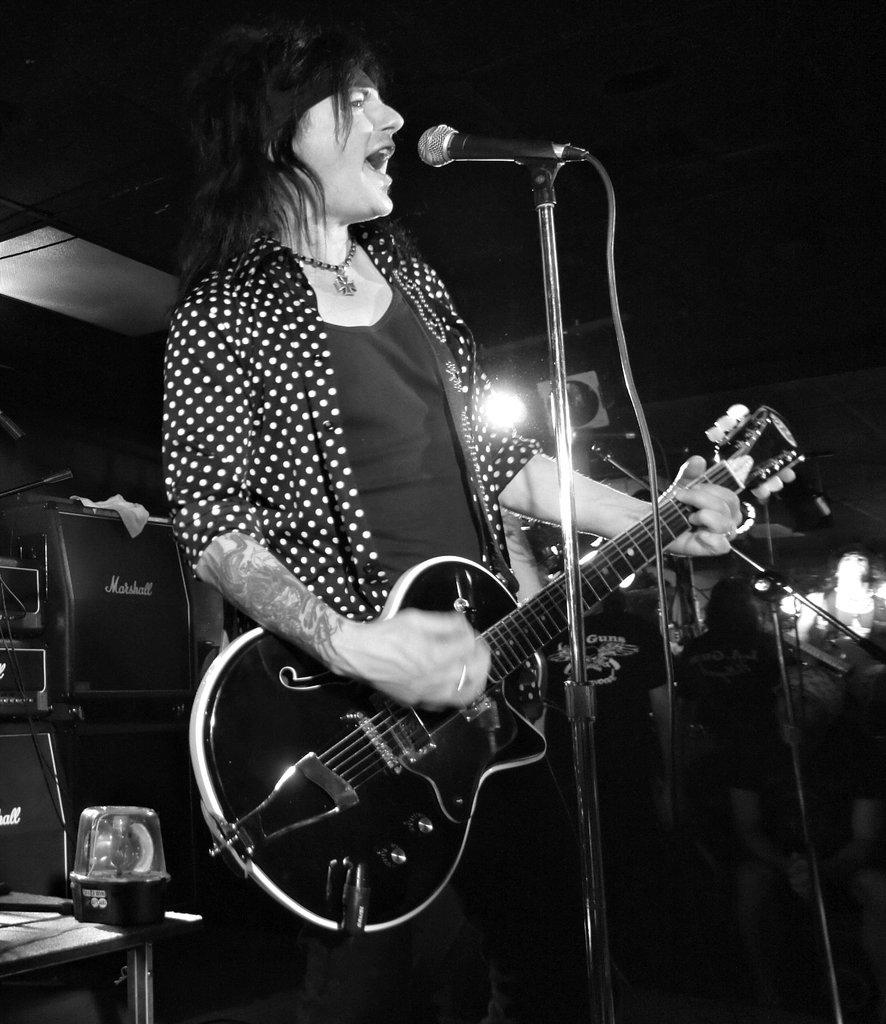What is the color scheme of the image? The image is black and white. What is the person in the image doing? The person is playing a guitar in the image. What object is present for amplifying sound? There is a microphone in the image. What piece of furniture can be seen in the image? There is a table in the image. What source of illumination is visible in the image? There is a light in the image. Are there any other objects present in the image? Yes, there are other objects in the image. What type of breakfast is being prepared on the table in the image? There is no breakfast or cooking activity present in the image; it features a person playing a guitar with a microphone and other objects. 